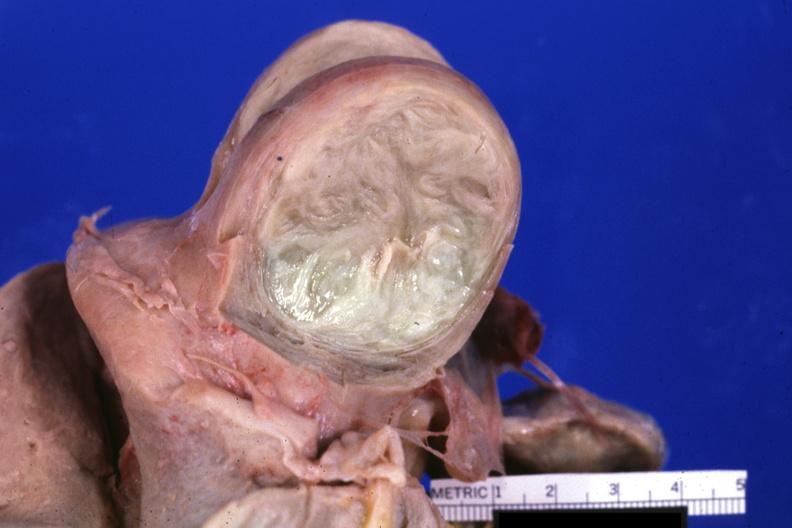what is present?
Answer the question using a single word or phrase. Leiomyoma 